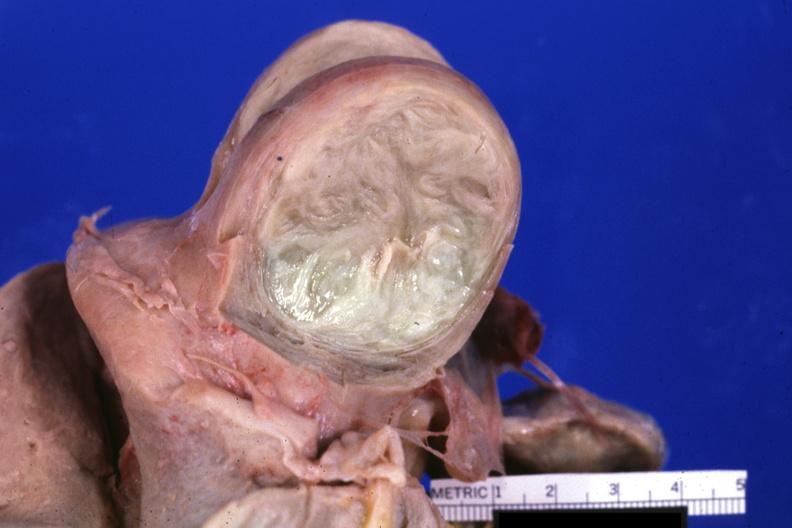what is present?
Answer the question using a single word or phrase. Leiomyoma 